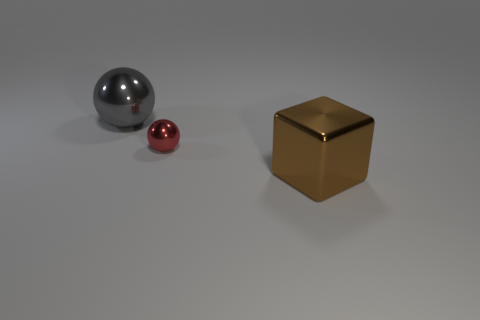There is a metal sphere right of the big metal object that is behind the large thing in front of the gray shiny object; how big is it?
Make the answer very short. Small. What number of small metallic things have the same color as the large cube?
Make the answer very short. 0. What number of objects are big brown things or metallic objects that are right of the tiny shiny ball?
Provide a succinct answer. 1. The tiny ball is what color?
Provide a succinct answer. Red. The large object that is right of the gray shiny object is what color?
Provide a succinct answer. Brown. What number of metallic objects are on the left side of the large object in front of the large shiny sphere?
Offer a very short reply. 2. Is the size of the red ball the same as the shiny object to the left of the tiny ball?
Your response must be concise. No. Is there a brown shiny thing that has the same size as the red object?
Offer a very short reply. No. What number of objects are large brown cylinders or red metallic balls?
Provide a short and direct response. 1. Is the size of the shiny thing that is behind the small thing the same as the sphere in front of the gray shiny thing?
Provide a short and direct response. No. 